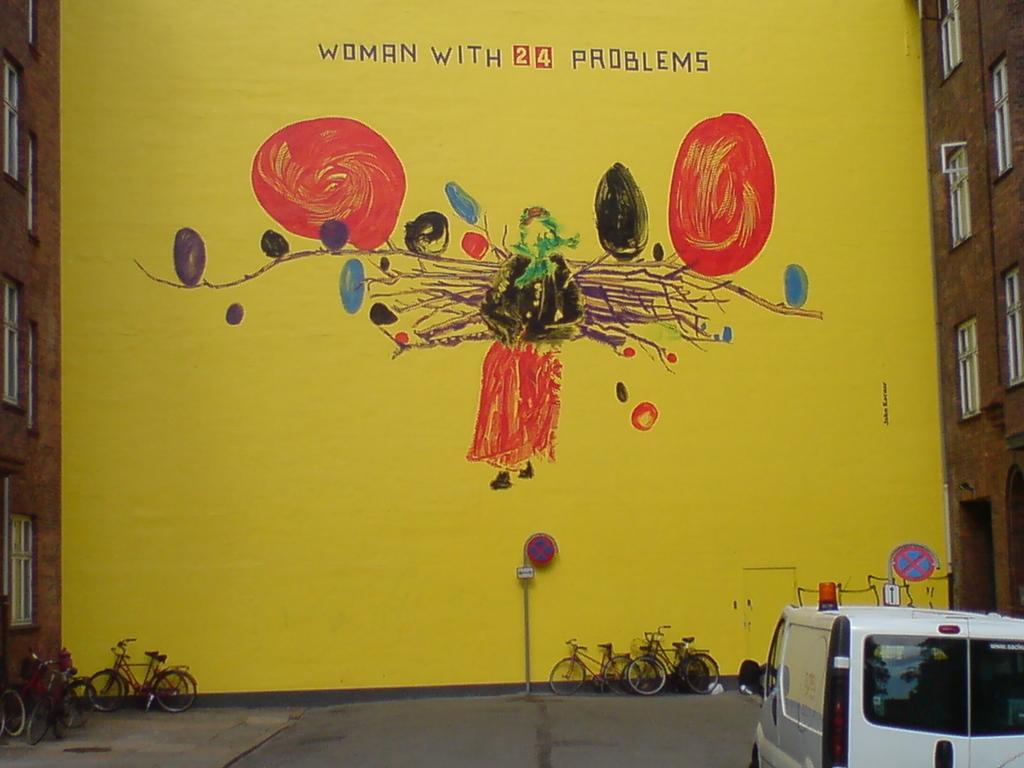In one or two sentences, can you explain what this image depicts? In this picture is a painting and there is a text on the board. On the right side of the image there is a vehicle. At the back there are bicycles and poles. On the left and on the right side of the image there is a building. At the bottom there is a road. 